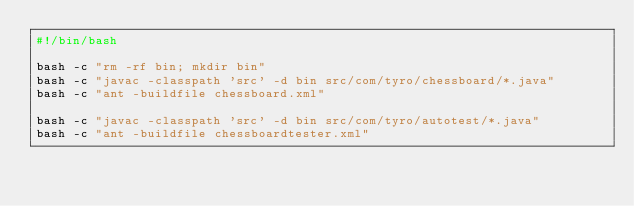Convert code to text. <code><loc_0><loc_0><loc_500><loc_500><_Bash_>#!/bin/bash

bash -c "rm -rf bin; mkdir bin"
bash -c "javac -classpath 'src' -d bin src/com/tyro/chessboard/*.java"
bash -c "ant -buildfile chessboard.xml"

bash -c "javac -classpath 'src' -d bin src/com/tyro/autotest/*.java"
bash -c "ant -buildfile chessboardtester.xml"

</code> 